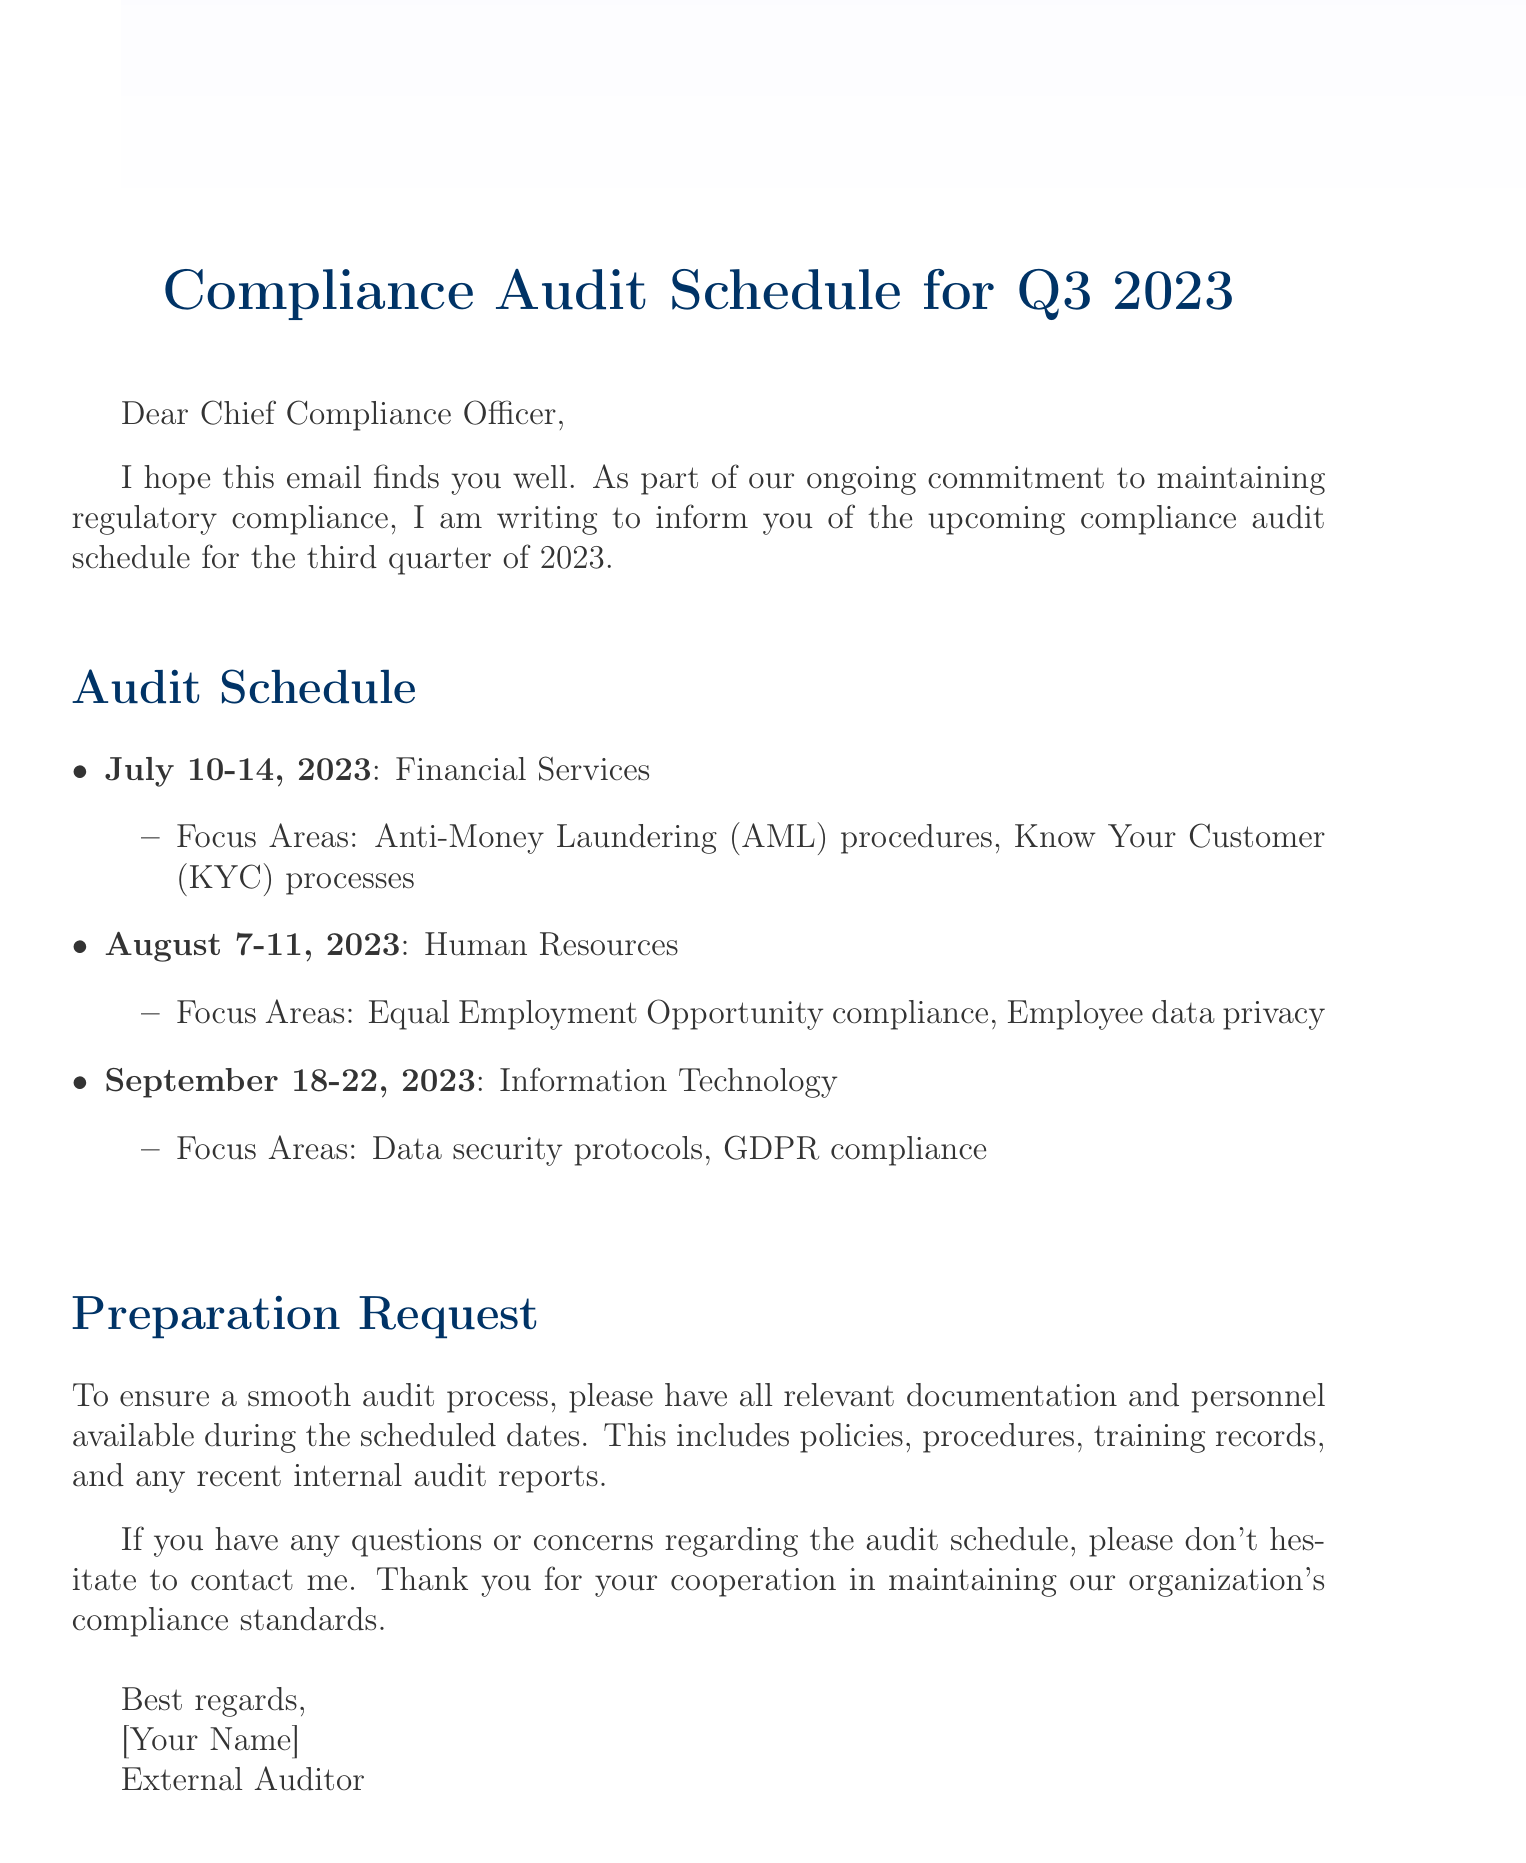What are the scheduled audit dates for Financial Services? The dates provided in the document state that the Financial Services audit is scheduled for July 10-14, 2023.
Answer: July 10-14, 2023 Which department is being audited in August? According to the audit schedule, the Human Resources department is scheduled for an audit in August.
Answer: Human Resources What focus area is included in the Information Technology audit? The document lists "Data security protocols" and "GDPR compliance" as focus areas for the Information Technology audit.
Answer: Data security protocols, GDPR compliance When is the audit for Human Resources taking place? The audit for the Human Resources department is scheduled for August 7-11, 2023, as stated in the document.
Answer: August 7-11, 2023 What preparation is requested for the audit process? The document specifies that relevant documentation and personnel should be available during the scheduled audit dates.
Answer: Relevant documentation and personnel What is the primary purpose of the compliance audits mentioned? The primary purpose, as detailed in the introduction, is to maintain regulatory compliance within the organization.
Answer: Maintain regulatory compliance How many departments are scheduled for audits in Q3 2023? The document lists three departments scheduled for audits in the third quarter of 2023.
Answer: Three departments What is the closing statement in the document? The closing statement indicates to contact the auditor for any questions or concerns regarding the audit schedule.
Answer: Contact me for any questions or concerns 